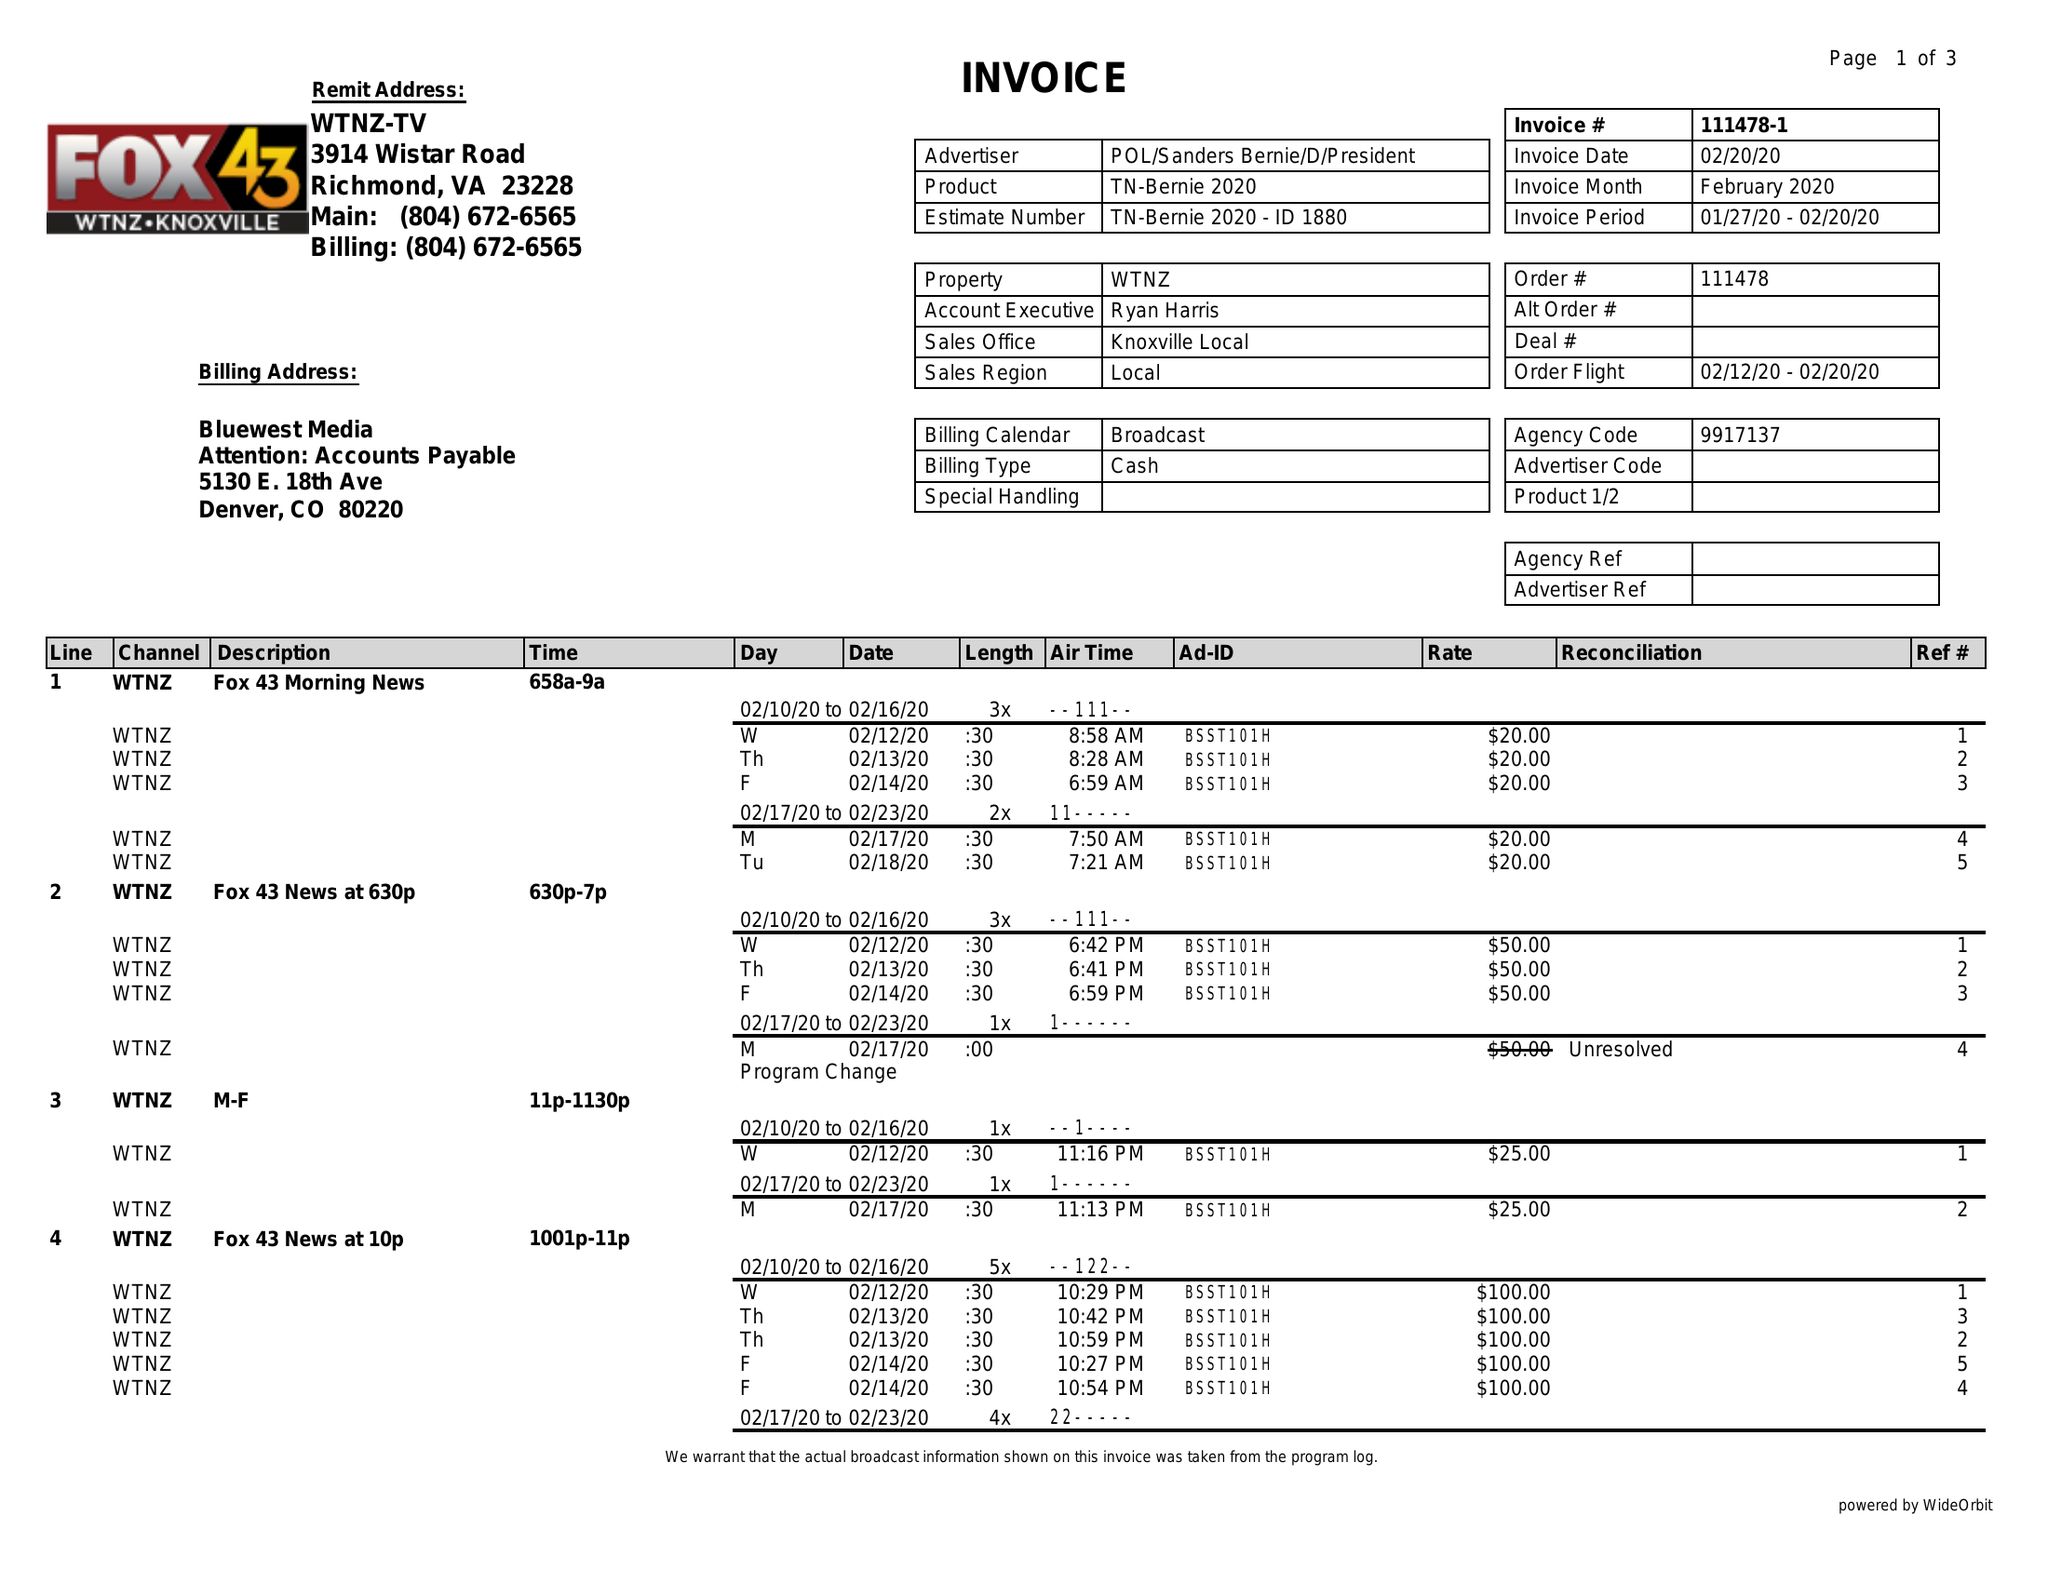What is the value for the contract_num?
Answer the question using a single word or phrase. 111478 